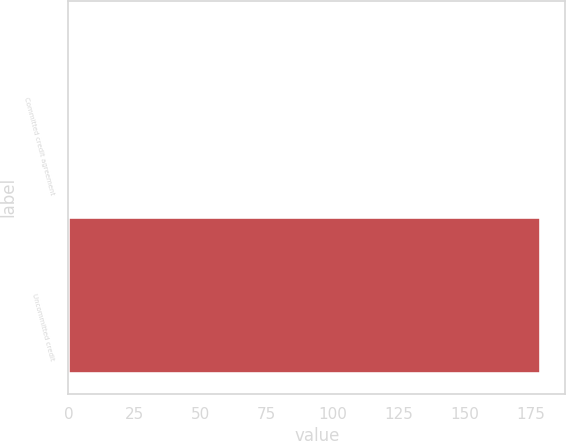Convert chart to OTSL. <chart><loc_0><loc_0><loc_500><loc_500><bar_chart><fcel>Committed credit agreement<fcel>Uncommitted credit<nl><fcel>0.47<fcel>179.1<nl></chart> 